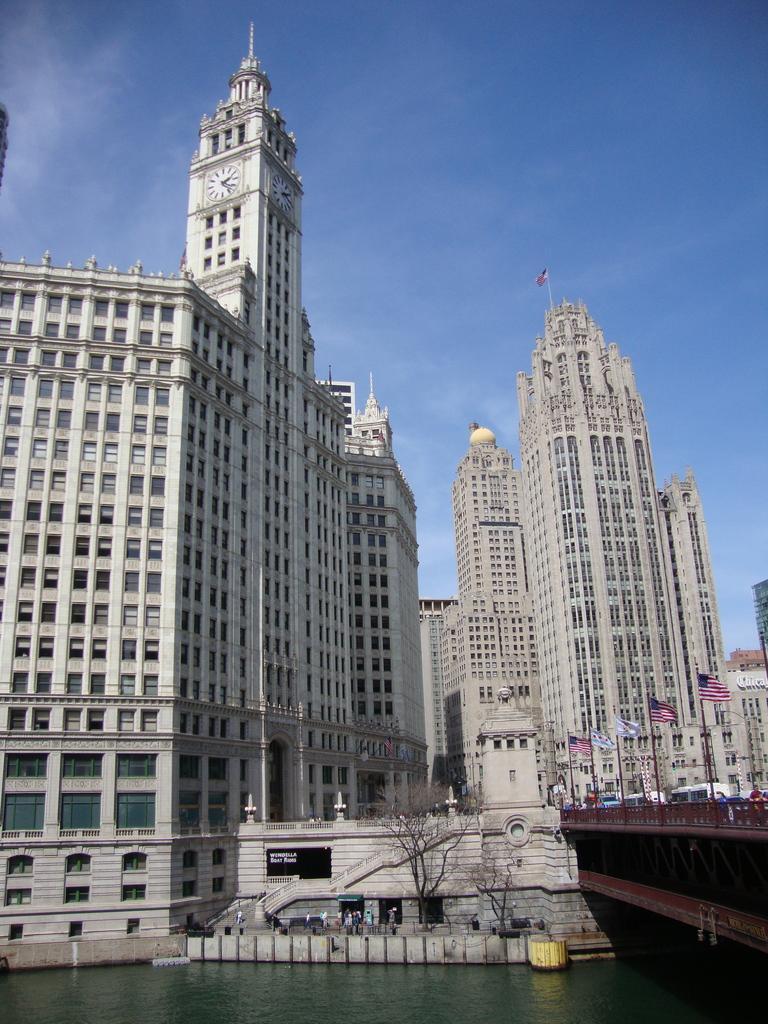Could you give a brief overview of what you see in this image? Sky is in blue color. In-front of his buildings there are flags, bare trees and water. Above this water there is a bridge. 